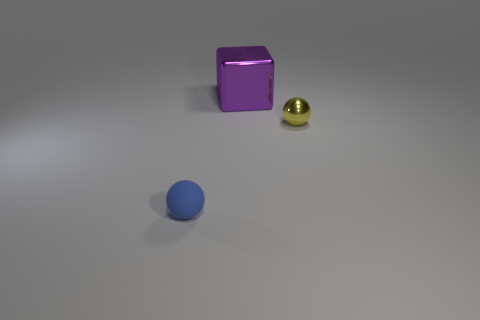There is a tiny yellow object behind the tiny blue rubber ball; does it have the same shape as the large purple metallic object behind the tiny blue object?
Keep it short and to the point. No. What number of objects are both to the right of the rubber object and in front of the large cube?
Offer a terse response. 1. Is there a rubber sphere of the same color as the tiny metallic thing?
Provide a succinct answer. No. There is a tiny yellow metallic sphere; are there any matte things behind it?
Offer a terse response. No. Does the tiny ball right of the rubber sphere have the same material as the sphere that is in front of the yellow metal thing?
Provide a short and direct response. No. What number of purple metal blocks have the same size as the matte ball?
Keep it short and to the point. 0. There is a tiny sphere that is to the right of the blue matte ball; what material is it?
Make the answer very short. Metal. What number of other large metallic objects have the same shape as the purple object?
Your answer should be compact. 0. What shape is the big purple object that is made of the same material as the tiny yellow object?
Offer a terse response. Cube. There is a tiny thing on the right side of the sphere that is in front of the small ball that is on the right side of the blue matte ball; what is its shape?
Make the answer very short. Sphere. 